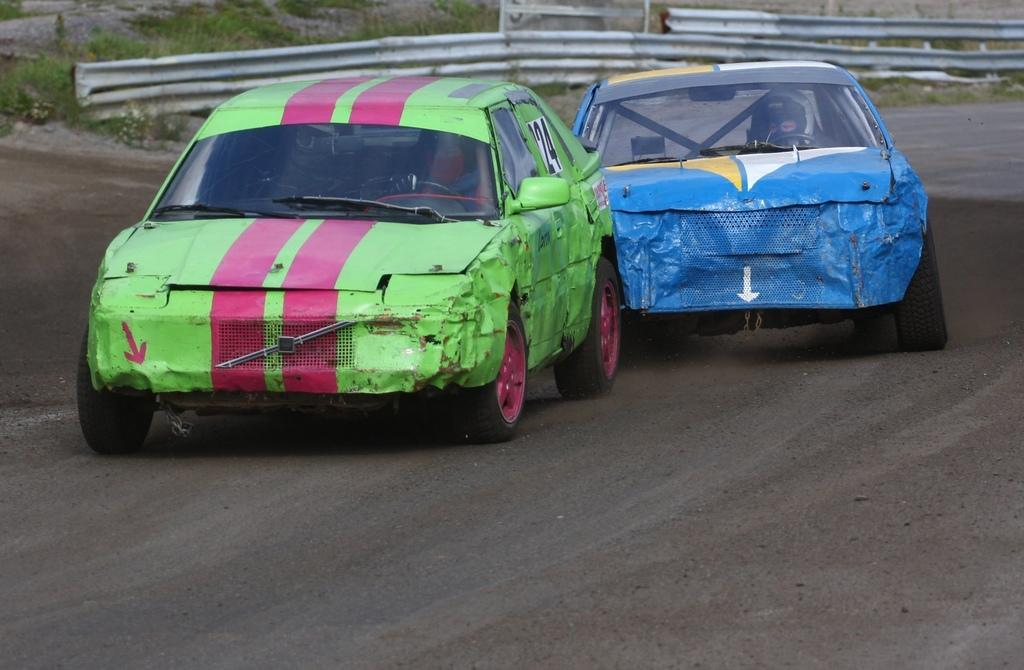What can be seen on the road in the image? There are vehicles on the road in the image. What is visible in the background of the image? There is a railing and grass visible in the background of the image. What type of cannon can be seen in the image? There is no cannon present in the image. How does the grass feel in the image? The image is a visual representation, so it is not possible to determine how the grass feels. 